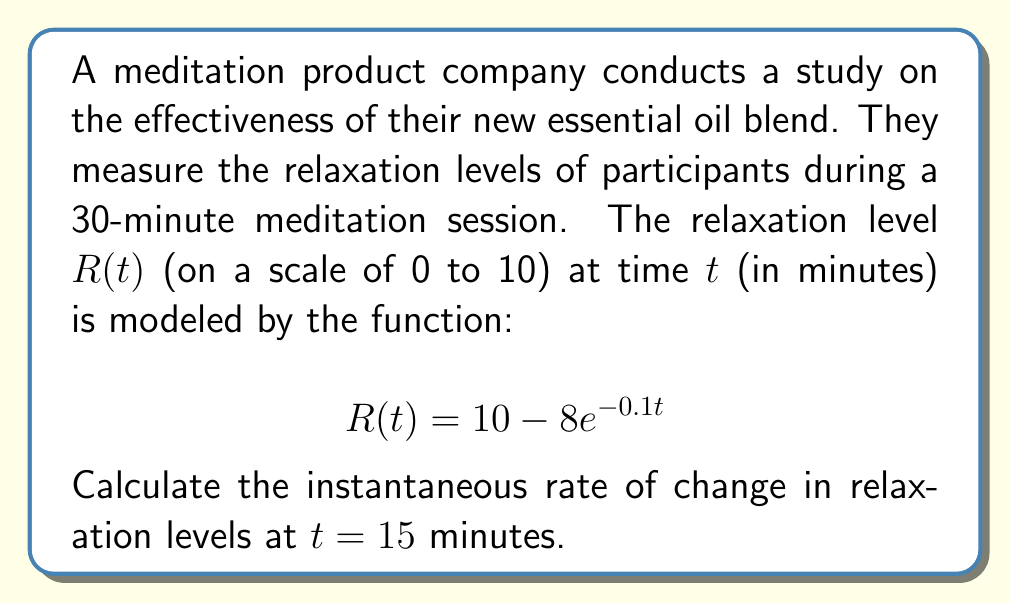Solve this math problem. To find the instantaneous rate of change at $t = 15$ minutes, we need to calculate the derivative of $R(t)$ and evaluate it at $t = 15$.

Step 1: Find the derivative of $R(t)$
$$\frac{d}{dt}R(t) = \frac{d}{dt}(10 - 8e^{-0.1t})$$
$$R'(t) = 0 - 8 \cdot \frac{d}{dt}(e^{-0.1t})$$
$$R'(t) = -8 \cdot (-0.1) \cdot e^{-0.1t}$$
$$R'(t) = 0.8e^{-0.1t}$$

Step 2: Evaluate $R'(t)$ at $t = 15$
$$R'(15) = 0.8e^{-0.1(15)}$$
$$R'(15) = 0.8e^{-1.5}$$
$$R'(15) \approx 0.1789$$

Therefore, the instantaneous rate of change in relaxation levels at $t = 15$ minutes is approximately 0.1789 units per minute.
Answer: $0.1789$ units/minute 